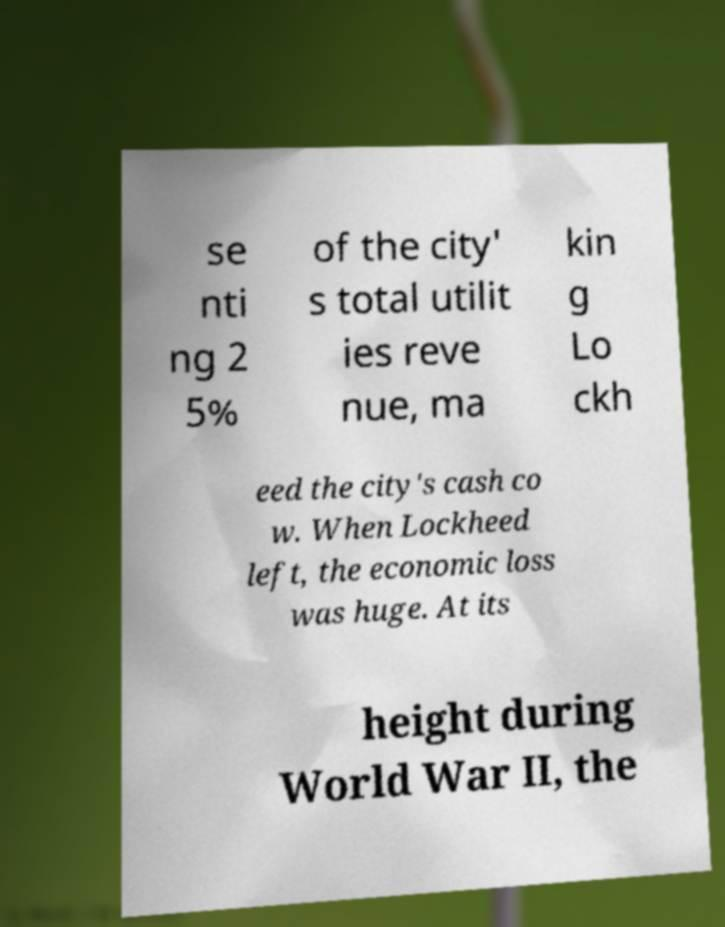Could you assist in decoding the text presented in this image and type it out clearly? se nti ng 2 5% of the city' s total utilit ies reve nue, ma kin g Lo ckh eed the city's cash co w. When Lockheed left, the economic loss was huge. At its height during World War II, the 